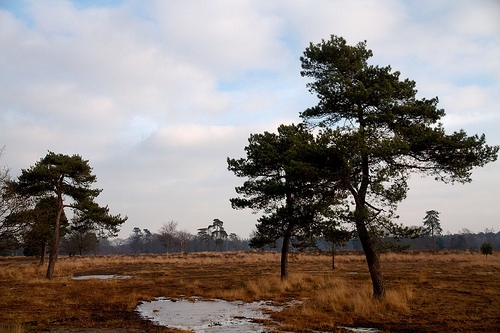<image>
Can you confirm if the tree is on the tree? No. The tree is not positioned on the tree. They may be near each other, but the tree is not supported by or resting on top of the tree. 